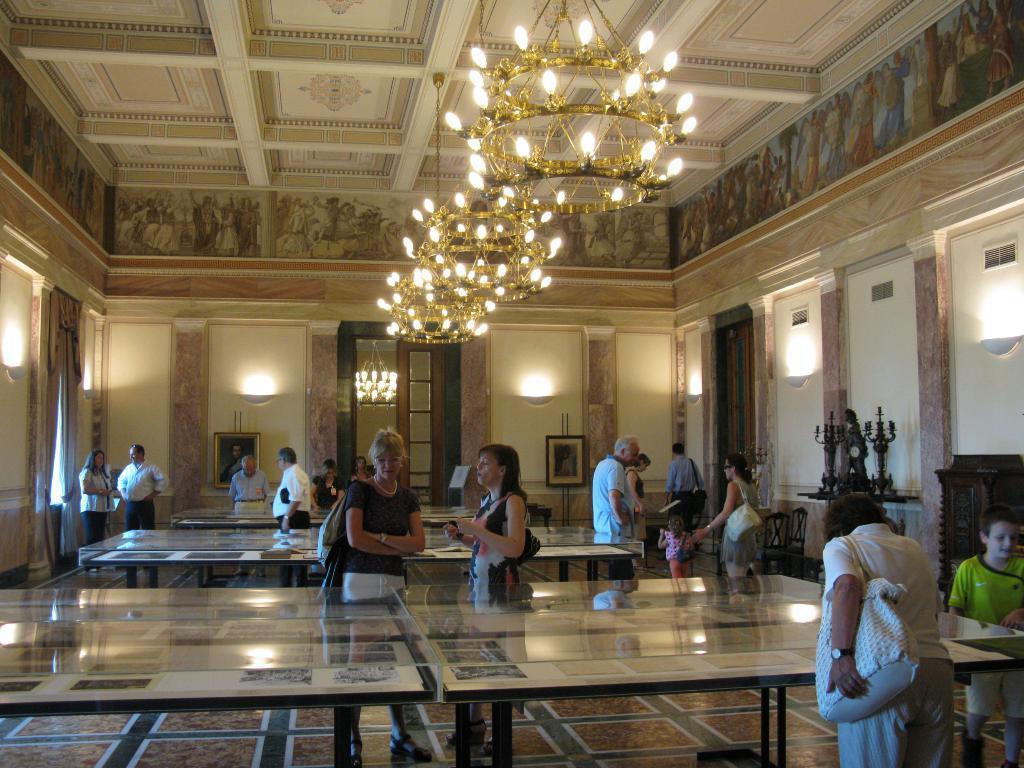Could you give a brief overview of what you see in this image? In the image i can see a inside view of a building. on the roof i can see a chandelier attached to the roof. And i can see number of people standing on the floor. On the right side i can see a girl wearing a green color shirt,and a woman holding a white color hand bag. i can see is some sculpture kept on the table and i can see photo frame attached to wall in the middle of the image. In the center i can see a tables kept on the floor. On the left side i can see a curtains attached to the wall. And i can see a painting attached to the wall. 